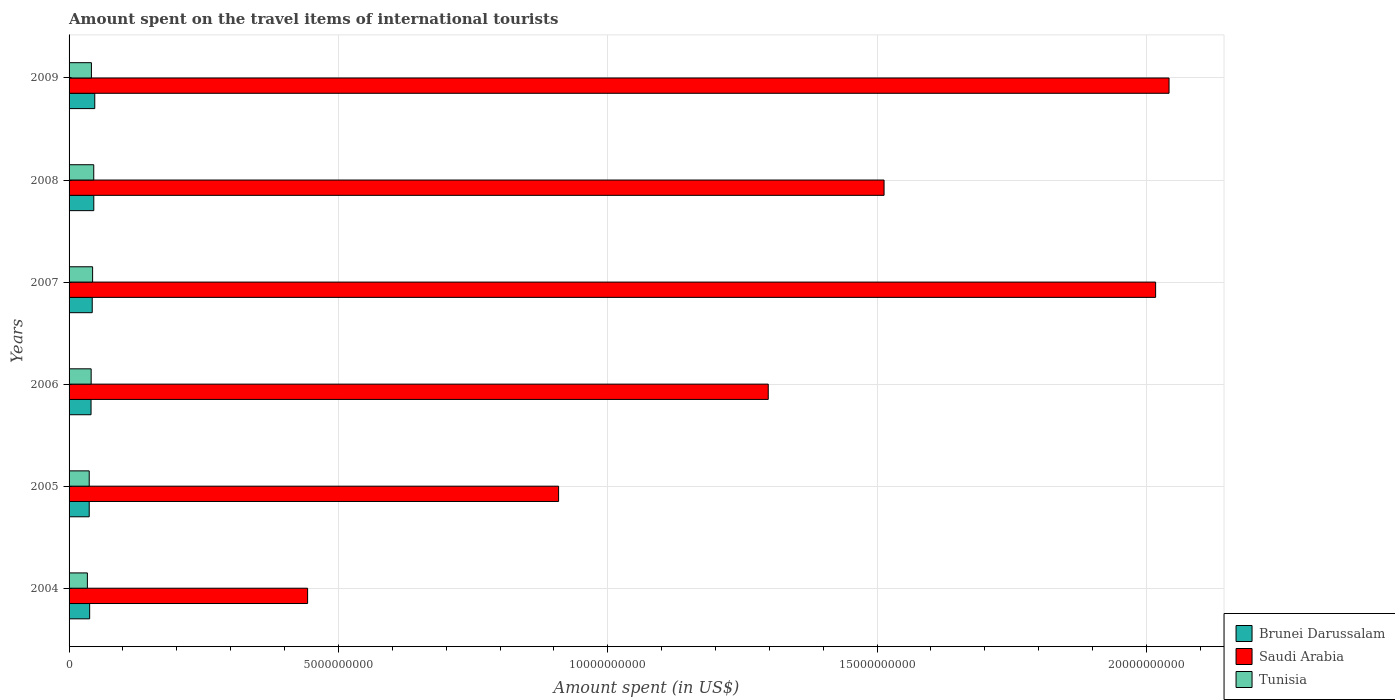How many groups of bars are there?
Provide a succinct answer. 6. Are the number of bars per tick equal to the number of legend labels?
Provide a short and direct response. Yes. Are the number of bars on each tick of the Y-axis equal?
Keep it short and to the point. Yes. How many bars are there on the 2nd tick from the top?
Your response must be concise. 3. How many bars are there on the 1st tick from the bottom?
Keep it short and to the point. 3. What is the label of the 5th group of bars from the top?
Your answer should be compact. 2005. In how many cases, is the number of bars for a given year not equal to the number of legend labels?
Offer a very short reply. 0. What is the amount spent on the travel items of international tourists in Brunei Darussalam in 2004?
Keep it short and to the point. 3.82e+08. Across all years, what is the maximum amount spent on the travel items of international tourists in Brunei Darussalam?
Your answer should be very brief. 4.77e+08. Across all years, what is the minimum amount spent on the travel items of international tourists in Brunei Darussalam?
Ensure brevity in your answer.  3.74e+08. In which year was the amount spent on the travel items of international tourists in Tunisia minimum?
Your response must be concise. 2004. What is the total amount spent on the travel items of international tourists in Brunei Darussalam in the graph?
Offer a very short reply. 2.53e+09. What is the difference between the amount spent on the travel items of international tourists in Saudi Arabia in 2004 and that in 2008?
Make the answer very short. -1.07e+1. What is the difference between the amount spent on the travel items of international tourists in Saudi Arabia in 2006 and the amount spent on the travel items of international tourists in Brunei Darussalam in 2007?
Give a very brief answer. 1.25e+1. What is the average amount spent on the travel items of international tourists in Saudi Arabia per year?
Provide a short and direct response. 1.37e+1. In the year 2009, what is the difference between the amount spent on the travel items of international tourists in Saudi Arabia and amount spent on the travel items of international tourists in Brunei Darussalam?
Give a very brief answer. 1.99e+1. What is the ratio of the amount spent on the travel items of international tourists in Tunisia in 2004 to that in 2006?
Ensure brevity in your answer.  0.83. Is the amount spent on the travel items of international tourists in Saudi Arabia in 2006 less than that in 2008?
Offer a very short reply. Yes. What is the difference between the highest and the second highest amount spent on the travel items of international tourists in Tunisia?
Provide a short and direct response. 2.10e+07. What is the difference between the highest and the lowest amount spent on the travel items of international tourists in Tunisia?
Provide a succinct answer. 1.18e+08. Is the sum of the amount spent on the travel items of international tourists in Tunisia in 2007 and 2008 greater than the maximum amount spent on the travel items of international tourists in Brunei Darussalam across all years?
Your answer should be very brief. Yes. What does the 2nd bar from the top in 2004 represents?
Your response must be concise. Saudi Arabia. What does the 1st bar from the bottom in 2005 represents?
Make the answer very short. Brunei Darussalam. How many bars are there?
Offer a terse response. 18. Are all the bars in the graph horizontal?
Offer a terse response. Yes. How many years are there in the graph?
Give a very brief answer. 6. What is the difference between two consecutive major ticks on the X-axis?
Provide a short and direct response. 5.00e+09. Are the values on the major ticks of X-axis written in scientific E-notation?
Make the answer very short. No. How many legend labels are there?
Make the answer very short. 3. What is the title of the graph?
Provide a succinct answer. Amount spent on the travel items of international tourists. Does "Rwanda" appear as one of the legend labels in the graph?
Your answer should be compact. No. What is the label or title of the X-axis?
Your response must be concise. Amount spent (in US$). What is the label or title of the Y-axis?
Ensure brevity in your answer.  Years. What is the Amount spent (in US$) in Brunei Darussalam in 2004?
Offer a terse response. 3.82e+08. What is the Amount spent (in US$) in Saudi Arabia in 2004?
Offer a terse response. 4.43e+09. What is the Amount spent (in US$) of Tunisia in 2004?
Ensure brevity in your answer.  3.40e+08. What is the Amount spent (in US$) of Brunei Darussalam in 2005?
Provide a short and direct response. 3.74e+08. What is the Amount spent (in US$) in Saudi Arabia in 2005?
Provide a succinct answer. 9.09e+09. What is the Amount spent (in US$) of Tunisia in 2005?
Make the answer very short. 3.74e+08. What is the Amount spent (in US$) of Brunei Darussalam in 2006?
Give a very brief answer. 4.08e+08. What is the Amount spent (in US$) in Saudi Arabia in 2006?
Keep it short and to the point. 1.30e+1. What is the Amount spent (in US$) of Tunisia in 2006?
Your response must be concise. 4.10e+08. What is the Amount spent (in US$) of Brunei Darussalam in 2007?
Offer a terse response. 4.30e+08. What is the Amount spent (in US$) in Saudi Arabia in 2007?
Give a very brief answer. 2.02e+1. What is the Amount spent (in US$) of Tunisia in 2007?
Give a very brief answer. 4.37e+08. What is the Amount spent (in US$) in Brunei Darussalam in 2008?
Ensure brevity in your answer.  4.59e+08. What is the Amount spent (in US$) in Saudi Arabia in 2008?
Provide a short and direct response. 1.51e+1. What is the Amount spent (in US$) in Tunisia in 2008?
Your answer should be very brief. 4.58e+08. What is the Amount spent (in US$) in Brunei Darussalam in 2009?
Your answer should be compact. 4.77e+08. What is the Amount spent (in US$) of Saudi Arabia in 2009?
Provide a short and direct response. 2.04e+1. What is the Amount spent (in US$) of Tunisia in 2009?
Give a very brief answer. 4.15e+08. Across all years, what is the maximum Amount spent (in US$) in Brunei Darussalam?
Offer a terse response. 4.77e+08. Across all years, what is the maximum Amount spent (in US$) of Saudi Arabia?
Ensure brevity in your answer.  2.04e+1. Across all years, what is the maximum Amount spent (in US$) of Tunisia?
Your answer should be compact. 4.58e+08. Across all years, what is the minimum Amount spent (in US$) in Brunei Darussalam?
Offer a terse response. 3.74e+08. Across all years, what is the minimum Amount spent (in US$) in Saudi Arabia?
Your answer should be very brief. 4.43e+09. Across all years, what is the minimum Amount spent (in US$) in Tunisia?
Offer a terse response. 3.40e+08. What is the total Amount spent (in US$) in Brunei Darussalam in the graph?
Offer a terse response. 2.53e+09. What is the total Amount spent (in US$) in Saudi Arabia in the graph?
Your response must be concise. 8.22e+1. What is the total Amount spent (in US$) in Tunisia in the graph?
Keep it short and to the point. 2.43e+09. What is the difference between the Amount spent (in US$) of Saudi Arabia in 2004 and that in 2005?
Give a very brief answer. -4.66e+09. What is the difference between the Amount spent (in US$) in Tunisia in 2004 and that in 2005?
Provide a short and direct response. -3.40e+07. What is the difference between the Amount spent (in US$) of Brunei Darussalam in 2004 and that in 2006?
Your answer should be compact. -2.60e+07. What is the difference between the Amount spent (in US$) of Saudi Arabia in 2004 and that in 2006?
Offer a terse response. -8.55e+09. What is the difference between the Amount spent (in US$) in Tunisia in 2004 and that in 2006?
Provide a succinct answer. -7.00e+07. What is the difference between the Amount spent (in US$) in Brunei Darussalam in 2004 and that in 2007?
Your answer should be compact. -4.80e+07. What is the difference between the Amount spent (in US$) of Saudi Arabia in 2004 and that in 2007?
Keep it short and to the point. -1.57e+1. What is the difference between the Amount spent (in US$) of Tunisia in 2004 and that in 2007?
Your answer should be very brief. -9.70e+07. What is the difference between the Amount spent (in US$) in Brunei Darussalam in 2004 and that in 2008?
Your answer should be compact. -7.70e+07. What is the difference between the Amount spent (in US$) of Saudi Arabia in 2004 and that in 2008?
Provide a short and direct response. -1.07e+1. What is the difference between the Amount spent (in US$) of Tunisia in 2004 and that in 2008?
Offer a terse response. -1.18e+08. What is the difference between the Amount spent (in US$) of Brunei Darussalam in 2004 and that in 2009?
Ensure brevity in your answer.  -9.50e+07. What is the difference between the Amount spent (in US$) in Saudi Arabia in 2004 and that in 2009?
Your answer should be very brief. -1.60e+1. What is the difference between the Amount spent (in US$) of Tunisia in 2004 and that in 2009?
Offer a very short reply. -7.50e+07. What is the difference between the Amount spent (in US$) of Brunei Darussalam in 2005 and that in 2006?
Provide a succinct answer. -3.40e+07. What is the difference between the Amount spent (in US$) in Saudi Arabia in 2005 and that in 2006?
Ensure brevity in your answer.  -3.89e+09. What is the difference between the Amount spent (in US$) of Tunisia in 2005 and that in 2006?
Your answer should be very brief. -3.60e+07. What is the difference between the Amount spent (in US$) of Brunei Darussalam in 2005 and that in 2007?
Your answer should be very brief. -5.60e+07. What is the difference between the Amount spent (in US$) of Saudi Arabia in 2005 and that in 2007?
Keep it short and to the point. -1.11e+1. What is the difference between the Amount spent (in US$) in Tunisia in 2005 and that in 2007?
Ensure brevity in your answer.  -6.30e+07. What is the difference between the Amount spent (in US$) of Brunei Darussalam in 2005 and that in 2008?
Keep it short and to the point. -8.50e+07. What is the difference between the Amount spent (in US$) of Saudi Arabia in 2005 and that in 2008?
Keep it short and to the point. -6.04e+09. What is the difference between the Amount spent (in US$) in Tunisia in 2005 and that in 2008?
Offer a very short reply. -8.40e+07. What is the difference between the Amount spent (in US$) in Brunei Darussalam in 2005 and that in 2009?
Your answer should be compact. -1.03e+08. What is the difference between the Amount spent (in US$) of Saudi Arabia in 2005 and that in 2009?
Your answer should be compact. -1.13e+1. What is the difference between the Amount spent (in US$) of Tunisia in 2005 and that in 2009?
Give a very brief answer. -4.10e+07. What is the difference between the Amount spent (in US$) of Brunei Darussalam in 2006 and that in 2007?
Your answer should be very brief. -2.20e+07. What is the difference between the Amount spent (in US$) in Saudi Arabia in 2006 and that in 2007?
Provide a succinct answer. -7.19e+09. What is the difference between the Amount spent (in US$) in Tunisia in 2006 and that in 2007?
Provide a succinct answer. -2.70e+07. What is the difference between the Amount spent (in US$) of Brunei Darussalam in 2006 and that in 2008?
Provide a short and direct response. -5.10e+07. What is the difference between the Amount spent (in US$) in Saudi Arabia in 2006 and that in 2008?
Provide a short and direct response. -2.15e+09. What is the difference between the Amount spent (in US$) in Tunisia in 2006 and that in 2008?
Keep it short and to the point. -4.80e+07. What is the difference between the Amount spent (in US$) in Brunei Darussalam in 2006 and that in 2009?
Offer a terse response. -6.90e+07. What is the difference between the Amount spent (in US$) in Saudi Arabia in 2006 and that in 2009?
Your response must be concise. -7.44e+09. What is the difference between the Amount spent (in US$) of Tunisia in 2006 and that in 2009?
Offer a very short reply. -5.00e+06. What is the difference between the Amount spent (in US$) of Brunei Darussalam in 2007 and that in 2008?
Provide a short and direct response. -2.90e+07. What is the difference between the Amount spent (in US$) of Saudi Arabia in 2007 and that in 2008?
Your response must be concise. 5.04e+09. What is the difference between the Amount spent (in US$) in Tunisia in 2007 and that in 2008?
Keep it short and to the point. -2.10e+07. What is the difference between the Amount spent (in US$) in Brunei Darussalam in 2007 and that in 2009?
Your answer should be compact. -4.70e+07. What is the difference between the Amount spent (in US$) in Saudi Arabia in 2007 and that in 2009?
Offer a terse response. -2.49e+08. What is the difference between the Amount spent (in US$) of Tunisia in 2007 and that in 2009?
Offer a terse response. 2.20e+07. What is the difference between the Amount spent (in US$) of Brunei Darussalam in 2008 and that in 2009?
Your response must be concise. -1.80e+07. What is the difference between the Amount spent (in US$) of Saudi Arabia in 2008 and that in 2009?
Ensure brevity in your answer.  -5.29e+09. What is the difference between the Amount spent (in US$) of Tunisia in 2008 and that in 2009?
Your answer should be compact. 4.30e+07. What is the difference between the Amount spent (in US$) of Brunei Darussalam in 2004 and the Amount spent (in US$) of Saudi Arabia in 2005?
Your answer should be very brief. -8.70e+09. What is the difference between the Amount spent (in US$) of Saudi Arabia in 2004 and the Amount spent (in US$) of Tunisia in 2005?
Ensure brevity in your answer.  4.05e+09. What is the difference between the Amount spent (in US$) of Brunei Darussalam in 2004 and the Amount spent (in US$) of Saudi Arabia in 2006?
Give a very brief answer. -1.26e+1. What is the difference between the Amount spent (in US$) in Brunei Darussalam in 2004 and the Amount spent (in US$) in Tunisia in 2006?
Your answer should be very brief. -2.80e+07. What is the difference between the Amount spent (in US$) in Saudi Arabia in 2004 and the Amount spent (in US$) in Tunisia in 2006?
Offer a very short reply. 4.02e+09. What is the difference between the Amount spent (in US$) in Brunei Darussalam in 2004 and the Amount spent (in US$) in Saudi Arabia in 2007?
Give a very brief answer. -1.98e+1. What is the difference between the Amount spent (in US$) in Brunei Darussalam in 2004 and the Amount spent (in US$) in Tunisia in 2007?
Provide a short and direct response. -5.50e+07. What is the difference between the Amount spent (in US$) of Saudi Arabia in 2004 and the Amount spent (in US$) of Tunisia in 2007?
Offer a terse response. 3.99e+09. What is the difference between the Amount spent (in US$) of Brunei Darussalam in 2004 and the Amount spent (in US$) of Saudi Arabia in 2008?
Your answer should be compact. -1.47e+1. What is the difference between the Amount spent (in US$) in Brunei Darussalam in 2004 and the Amount spent (in US$) in Tunisia in 2008?
Your answer should be compact. -7.60e+07. What is the difference between the Amount spent (in US$) in Saudi Arabia in 2004 and the Amount spent (in US$) in Tunisia in 2008?
Provide a short and direct response. 3.97e+09. What is the difference between the Amount spent (in US$) of Brunei Darussalam in 2004 and the Amount spent (in US$) of Saudi Arabia in 2009?
Your answer should be compact. -2.00e+1. What is the difference between the Amount spent (in US$) in Brunei Darussalam in 2004 and the Amount spent (in US$) in Tunisia in 2009?
Make the answer very short. -3.30e+07. What is the difference between the Amount spent (in US$) of Saudi Arabia in 2004 and the Amount spent (in US$) of Tunisia in 2009?
Your answer should be very brief. 4.01e+09. What is the difference between the Amount spent (in US$) of Brunei Darussalam in 2005 and the Amount spent (in US$) of Saudi Arabia in 2006?
Your answer should be compact. -1.26e+1. What is the difference between the Amount spent (in US$) of Brunei Darussalam in 2005 and the Amount spent (in US$) of Tunisia in 2006?
Offer a terse response. -3.60e+07. What is the difference between the Amount spent (in US$) in Saudi Arabia in 2005 and the Amount spent (in US$) in Tunisia in 2006?
Your answer should be very brief. 8.68e+09. What is the difference between the Amount spent (in US$) of Brunei Darussalam in 2005 and the Amount spent (in US$) of Saudi Arabia in 2007?
Provide a short and direct response. -1.98e+1. What is the difference between the Amount spent (in US$) in Brunei Darussalam in 2005 and the Amount spent (in US$) in Tunisia in 2007?
Offer a very short reply. -6.30e+07. What is the difference between the Amount spent (in US$) of Saudi Arabia in 2005 and the Amount spent (in US$) of Tunisia in 2007?
Your response must be concise. 8.65e+09. What is the difference between the Amount spent (in US$) in Brunei Darussalam in 2005 and the Amount spent (in US$) in Saudi Arabia in 2008?
Provide a succinct answer. -1.48e+1. What is the difference between the Amount spent (in US$) of Brunei Darussalam in 2005 and the Amount spent (in US$) of Tunisia in 2008?
Ensure brevity in your answer.  -8.40e+07. What is the difference between the Amount spent (in US$) of Saudi Arabia in 2005 and the Amount spent (in US$) of Tunisia in 2008?
Your answer should be very brief. 8.63e+09. What is the difference between the Amount spent (in US$) of Brunei Darussalam in 2005 and the Amount spent (in US$) of Saudi Arabia in 2009?
Ensure brevity in your answer.  -2.00e+1. What is the difference between the Amount spent (in US$) of Brunei Darussalam in 2005 and the Amount spent (in US$) of Tunisia in 2009?
Provide a short and direct response. -4.10e+07. What is the difference between the Amount spent (in US$) of Saudi Arabia in 2005 and the Amount spent (in US$) of Tunisia in 2009?
Make the answer very short. 8.67e+09. What is the difference between the Amount spent (in US$) in Brunei Darussalam in 2006 and the Amount spent (in US$) in Saudi Arabia in 2007?
Your answer should be very brief. -1.98e+1. What is the difference between the Amount spent (in US$) of Brunei Darussalam in 2006 and the Amount spent (in US$) of Tunisia in 2007?
Offer a terse response. -2.90e+07. What is the difference between the Amount spent (in US$) in Saudi Arabia in 2006 and the Amount spent (in US$) in Tunisia in 2007?
Provide a short and direct response. 1.25e+1. What is the difference between the Amount spent (in US$) in Brunei Darussalam in 2006 and the Amount spent (in US$) in Saudi Arabia in 2008?
Provide a succinct answer. -1.47e+1. What is the difference between the Amount spent (in US$) in Brunei Darussalam in 2006 and the Amount spent (in US$) in Tunisia in 2008?
Provide a short and direct response. -5.00e+07. What is the difference between the Amount spent (in US$) of Saudi Arabia in 2006 and the Amount spent (in US$) of Tunisia in 2008?
Give a very brief answer. 1.25e+1. What is the difference between the Amount spent (in US$) in Brunei Darussalam in 2006 and the Amount spent (in US$) in Saudi Arabia in 2009?
Make the answer very short. -2.00e+1. What is the difference between the Amount spent (in US$) in Brunei Darussalam in 2006 and the Amount spent (in US$) in Tunisia in 2009?
Keep it short and to the point. -7.00e+06. What is the difference between the Amount spent (in US$) of Saudi Arabia in 2006 and the Amount spent (in US$) of Tunisia in 2009?
Keep it short and to the point. 1.26e+1. What is the difference between the Amount spent (in US$) in Brunei Darussalam in 2007 and the Amount spent (in US$) in Saudi Arabia in 2008?
Give a very brief answer. -1.47e+1. What is the difference between the Amount spent (in US$) of Brunei Darussalam in 2007 and the Amount spent (in US$) of Tunisia in 2008?
Keep it short and to the point. -2.80e+07. What is the difference between the Amount spent (in US$) in Saudi Arabia in 2007 and the Amount spent (in US$) in Tunisia in 2008?
Your answer should be very brief. 1.97e+1. What is the difference between the Amount spent (in US$) of Brunei Darussalam in 2007 and the Amount spent (in US$) of Saudi Arabia in 2009?
Ensure brevity in your answer.  -2.00e+1. What is the difference between the Amount spent (in US$) of Brunei Darussalam in 2007 and the Amount spent (in US$) of Tunisia in 2009?
Provide a succinct answer. 1.50e+07. What is the difference between the Amount spent (in US$) of Saudi Arabia in 2007 and the Amount spent (in US$) of Tunisia in 2009?
Keep it short and to the point. 1.98e+1. What is the difference between the Amount spent (in US$) of Brunei Darussalam in 2008 and the Amount spent (in US$) of Saudi Arabia in 2009?
Offer a terse response. -2.00e+1. What is the difference between the Amount spent (in US$) in Brunei Darussalam in 2008 and the Amount spent (in US$) in Tunisia in 2009?
Make the answer very short. 4.40e+07. What is the difference between the Amount spent (in US$) of Saudi Arabia in 2008 and the Amount spent (in US$) of Tunisia in 2009?
Offer a terse response. 1.47e+1. What is the average Amount spent (in US$) of Brunei Darussalam per year?
Give a very brief answer. 4.22e+08. What is the average Amount spent (in US$) of Saudi Arabia per year?
Your answer should be very brief. 1.37e+1. What is the average Amount spent (in US$) of Tunisia per year?
Offer a very short reply. 4.06e+08. In the year 2004, what is the difference between the Amount spent (in US$) in Brunei Darussalam and Amount spent (in US$) in Saudi Arabia?
Give a very brief answer. -4.05e+09. In the year 2004, what is the difference between the Amount spent (in US$) in Brunei Darussalam and Amount spent (in US$) in Tunisia?
Offer a terse response. 4.20e+07. In the year 2004, what is the difference between the Amount spent (in US$) in Saudi Arabia and Amount spent (in US$) in Tunisia?
Give a very brief answer. 4.09e+09. In the year 2005, what is the difference between the Amount spent (in US$) in Brunei Darussalam and Amount spent (in US$) in Saudi Arabia?
Keep it short and to the point. -8.71e+09. In the year 2005, what is the difference between the Amount spent (in US$) in Saudi Arabia and Amount spent (in US$) in Tunisia?
Give a very brief answer. 8.71e+09. In the year 2006, what is the difference between the Amount spent (in US$) of Brunei Darussalam and Amount spent (in US$) of Saudi Arabia?
Keep it short and to the point. -1.26e+1. In the year 2006, what is the difference between the Amount spent (in US$) in Saudi Arabia and Amount spent (in US$) in Tunisia?
Offer a very short reply. 1.26e+1. In the year 2007, what is the difference between the Amount spent (in US$) of Brunei Darussalam and Amount spent (in US$) of Saudi Arabia?
Make the answer very short. -1.97e+1. In the year 2007, what is the difference between the Amount spent (in US$) of Brunei Darussalam and Amount spent (in US$) of Tunisia?
Offer a terse response. -7.00e+06. In the year 2007, what is the difference between the Amount spent (in US$) of Saudi Arabia and Amount spent (in US$) of Tunisia?
Offer a terse response. 1.97e+1. In the year 2008, what is the difference between the Amount spent (in US$) in Brunei Darussalam and Amount spent (in US$) in Saudi Arabia?
Ensure brevity in your answer.  -1.47e+1. In the year 2008, what is the difference between the Amount spent (in US$) of Brunei Darussalam and Amount spent (in US$) of Tunisia?
Offer a very short reply. 1.00e+06. In the year 2008, what is the difference between the Amount spent (in US$) in Saudi Arabia and Amount spent (in US$) in Tunisia?
Ensure brevity in your answer.  1.47e+1. In the year 2009, what is the difference between the Amount spent (in US$) of Brunei Darussalam and Amount spent (in US$) of Saudi Arabia?
Your answer should be compact. -1.99e+1. In the year 2009, what is the difference between the Amount spent (in US$) of Brunei Darussalam and Amount spent (in US$) of Tunisia?
Your answer should be very brief. 6.20e+07. In the year 2009, what is the difference between the Amount spent (in US$) in Saudi Arabia and Amount spent (in US$) in Tunisia?
Ensure brevity in your answer.  2.00e+1. What is the ratio of the Amount spent (in US$) in Brunei Darussalam in 2004 to that in 2005?
Make the answer very short. 1.02. What is the ratio of the Amount spent (in US$) of Saudi Arabia in 2004 to that in 2005?
Offer a very short reply. 0.49. What is the ratio of the Amount spent (in US$) of Brunei Darussalam in 2004 to that in 2006?
Give a very brief answer. 0.94. What is the ratio of the Amount spent (in US$) in Saudi Arabia in 2004 to that in 2006?
Give a very brief answer. 0.34. What is the ratio of the Amount spent (in US$) of Tunisia in 2004 to that in 2006?
Offer a terse response. 0.83. What is the ratio of the Amount spent (in US$) in Brunei Darussalam in 2004 to that in 2007?
Your answer should be compact. 0.89. What is the ratio of the Amount spent (in US$) in Saudi Arabia in 2004 to that in 2007?
Your answer should be very brief. 0.22. What is the ratio of the Amount spent (in US$) in Tunisia in 2004 to that in 2007?
Your answer should be compact. 0.78. What is the ratio of the Amount spent (in US$) in Brunei Darussalam in 2004 to that in 2008?
Your response must be concise. 0.83. What is the ratio of the Amount spent (in US$) of Saudi Arabia in 2004 to that in 2008?
Ensure brevity in your answer.  0.29. What is the ratio of the Amount spent (in US$) in Tunisia in 2004 to that in 2008?
Give a very brief answer. 0.74. What is the ratio of the Amount spent (in US$) of Brunei Darussalam in 2004 to that in 2009?
Offer a very short reply. 0.8. What is the ratio of the Amount spent (in US$) in Saudi Arabia in 2004 to that in 2009?
Offer a very short reply. 0.22. What is the ratio of the Amount spent (in US$) of Tunisia in 2004 to that in 2009?
Your answer should be compact. 0.82. What is the ratio of the Amount spent (in US$) of Brunei Darussalam in 2005 to that in 2006?
Keep it short and to the point. 0.92. What is the ratio of the Amount spent (in US$) of Saudi Arabia in 2005 to that in 2006?
Ensure brevity in your answer.  0.7. What is the ratio of the Amount spent (in US$) of Tunisia in 2005 to that in 2006?
Offer a very short reply. 0.91. What is the ratio of the Amount spent (in US$) in Brunei Darussalam in 2005 to that in 2007?
Provide a short and direct response. 0.87. What is the ratio of the Amount spent (in US$) of Saudi Arabia in 2005 to that in 2007?
Your answer should be compact. 0.45. What is the ratio of the Amount spent (in US$) in Tunisia in 2005 to that in 2007?
Ensure brevity in your answer.  0.86. What is the ratio of the Amount spent (in US$) of Brunei Darussalam in 2005 to that in 2008?
Keep it short and to the point. 0.81. What is the ratio of the Amount spent (in US$) of Saudi Arabia in 2005 to that in 2008?
Ensure brevity in your answer.  0.6. What is the ratio of the Amount spent (in US$) in Tunisia in 2005 to that in 2008?
Keep it short and to the point. 0.82. What is the ratio of the Amount spent (in US$) in Brunei Darussalam in 2005 to that in 2009?
Provide a succinct answer. 0.78. What is the ratio of the Amount spent (in US$) of Saudi Arabia in 2005 to that in 2009?
Your answer should be compact. 0.45. What is the ratio of the Amount spent (in US$) of Tunisia in 2005 to that in 2009?
Provide a short and direct response. 0.9. What is the ratio of the Amount spent (in US$) of Brunei Darussalam in 2006 to that in 2007?
Make the answer very short. 0.95. What is the ratio of the Amount spent (in US$) in Saudi Arabia in 2006 to that in 2007?
Offer a terse response. 0.64. What is the ratio of the Amount spent (in US$) of Tunisia in 2006 to that in 2007?
Ensure brevity in your answer.  0.94. What is the ratio of the Amount spent (in US$) of Saudi Arabia in 2006 to that in 2008?
Keep it short and to the point. 0.86. What is the ratio of the Amount spent (in US$) of Tunisia in 2006 to that in 2008?
Provide a short and direct response. 0.9. What is the ratio of the Amount spent (in US$) in Brunei Darussalam in 2006 to that in 2009?
Ensure brevity in your answer.  0.86. What is the ratio of the Amount spent (in US$) of Saudi Arabia in 2006 to that in 2009?
Ensure brevity in your answer.  0.64. What is the ratio of the Amount spent (in US$) in Brunei Darussalam in 2007 to that in 2008?
Make the answer very short. 0.94. What is the ratio of the Amount spent (in US$) in Saudi Arabia in 2007 to that in 2008?
Give a very brief answer. 1.33. What is the ratio of the Amount spent (in US$) of Tunisia in 2007 to that in 2008?
Give a very brief answer. 0.95. What is the ratio of the Amount spent (in US$) of Brunei Darussalam in 2007 to that in 2009?
Provide a short and direct response. 0.9. What is the ratio of the Amount spent (in US$) of Saudi Arabia in 2007 to that in 2009?
Provide a succinct answer. 0.99. What is the ratio of the Amount spent (in US$) of Tunisia in 2007 to that in 2009?
Your response must be concise. 1.05. What is the ratio of the Amount spent (in US$) of Brunei Darussalam in 2008 to that in 2009?
Offer a very short reply. 0.96. What is the ratio of the Amount spent (in US$) in Saudi Arabia in 2008 to that in 2009?
Your answer should be compact. 0.74. What is the ratio of the Amount spent (in US$) of Tunisia in 2008 to that in 2009?
Make the answer very short. 1.1. What is the difference between the highest and the second highest Amount spent (in US$) in Brunei Darussalam?
Give a very brief answer. 1.80e+07. What is the difference between the highest and the second highest Amount spent (in US$) in Saudi Arabia?
Give a very brief answer. 2.49e+08. What is the difference between the highest and the second highest Amount spent (in US$) in Tunisia?
Ensure brevity in your answer.  2.10e+07. What is the difference between the highest and the lowest Amount spent (in US$) of Brunei Darussalam?
Give a very brief answer. 1.03e+08. What is the difference between the highest and the lowest Amount spent (in US$) in Saudi Arabia?
Ensure brevity in your answer.  1.60e+1. What is the difference between the highest and the lowest Amount spent (in US$) in Tunisia?
Provide a succinct answer. 1.18e+08. 